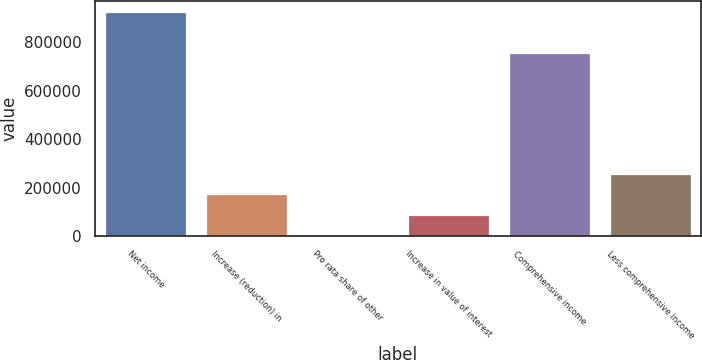Convert chart to OTSL. <chart><loc_0><loc_0><loc_500><loc_500><bar_chart><fcel>Net income<fcel>Increase (reduction) in<fcel>Pro rata share of other<fcel>Increase in value of interest<fcel>Comprehensive income<fcel>Less comprehensive income<nl><fcel>926274<fcel>172148<fcel>327<fcel>86237.3<fcel>754453<fcel>258058<nl></chart> 